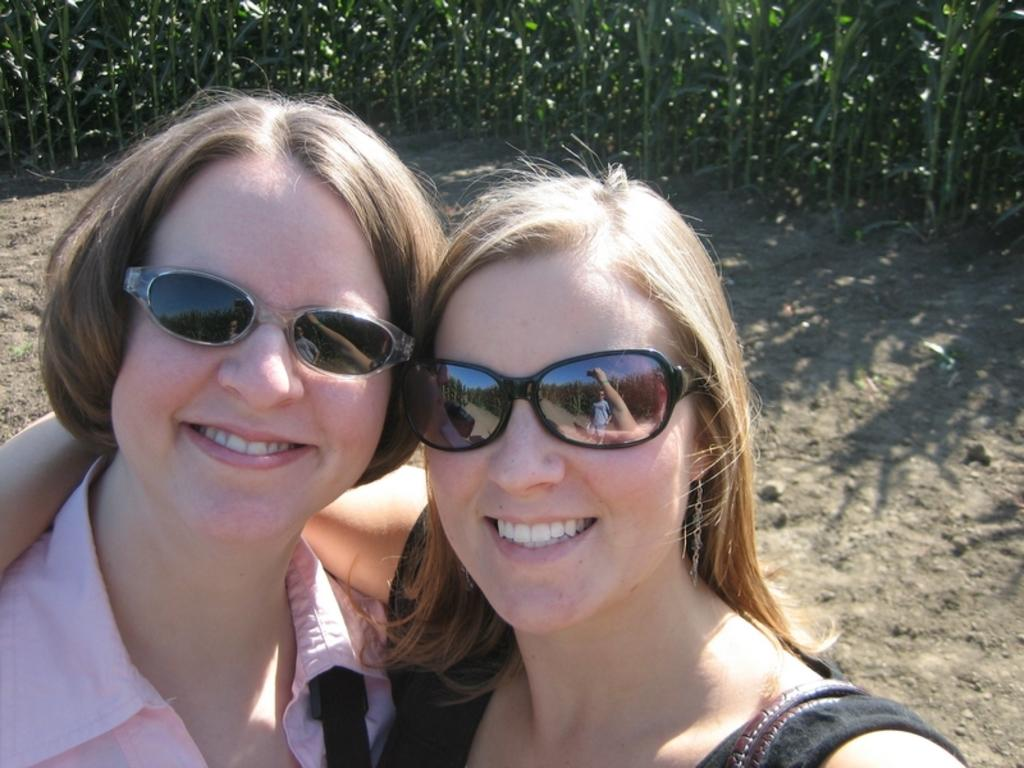How many people are in the image? There are two women in the picture. What are the women wearing on their faces? The women are wearing goggles. What expression do the women have in the image? The women are smiling. What can be seen in the background of the picture? There are trees in the background of the picture. What type of glue is being used by the women in the image? There is no glue present in the image; the women are wearing goggles and smiling. How many needles can be seen in the image? There are no needles present in the image; the women are wearing goggles and smiling. 